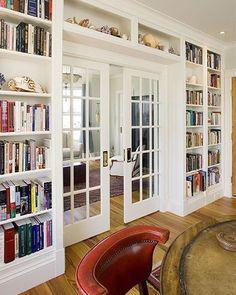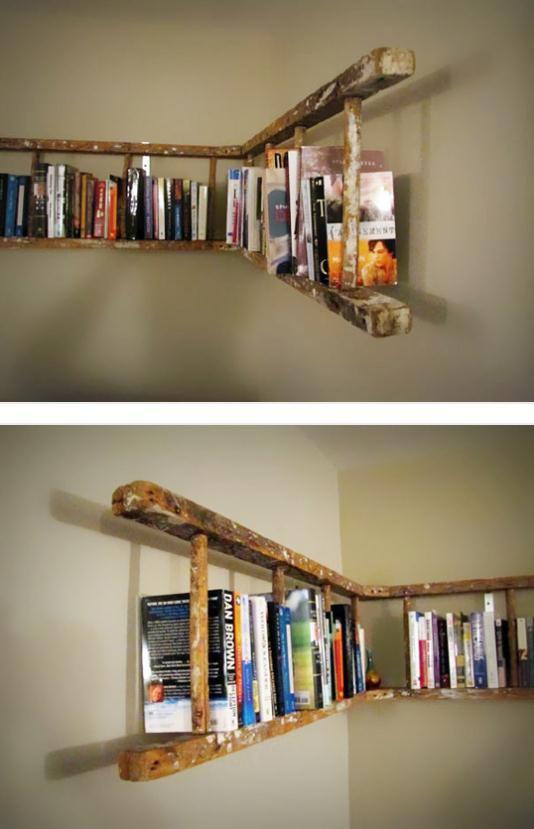The first image is the image on the left, the second image is the image on the right. Evaluate the accuracy of this statement regarding the images: "An image shows a hanging corner shelf style without back or sides.". Is it true? Answer yes or no. Yes. The first image is the image on the left, the second image is the image on the right. For the images shown, is this caption "In one image, small shelves attached directly to the wall wrap around a corner." true? Answer yes or no. Yes. 